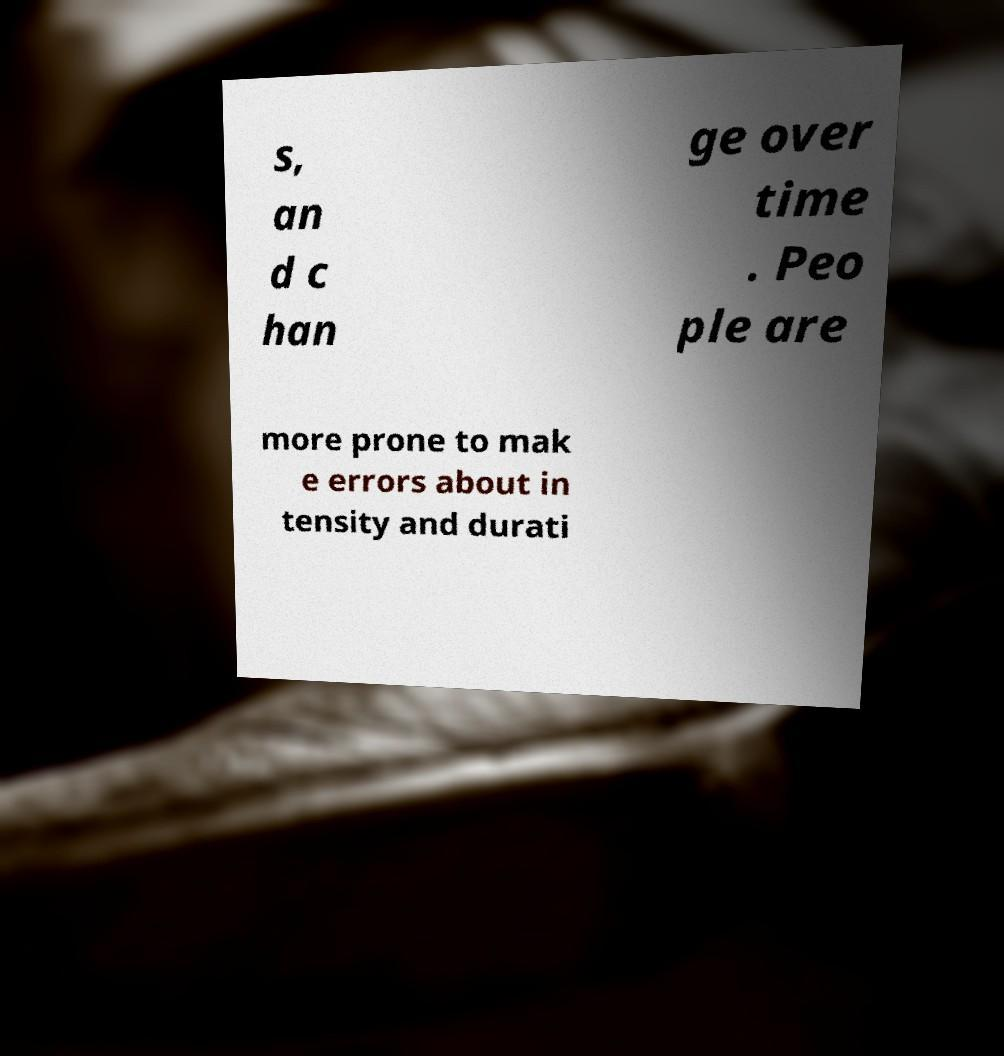There's text embedded in this image that I need extracted. Can you transcribe it verbatim? s, an d c han ge over time . Peo ple are more prone to mak e errors about in tensity and durati 